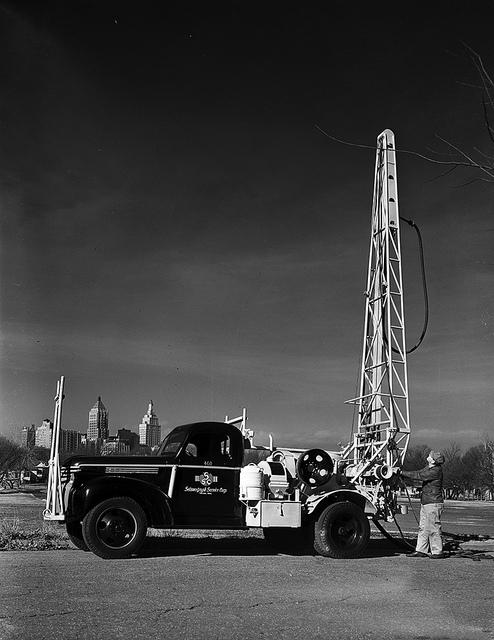Does the vehicle have attachments?
Give a very brief answer. Yes. Is this a truck?
Keep it brief. Yes. What kind of photograph is this?
Write a very short answer. Black and white. 